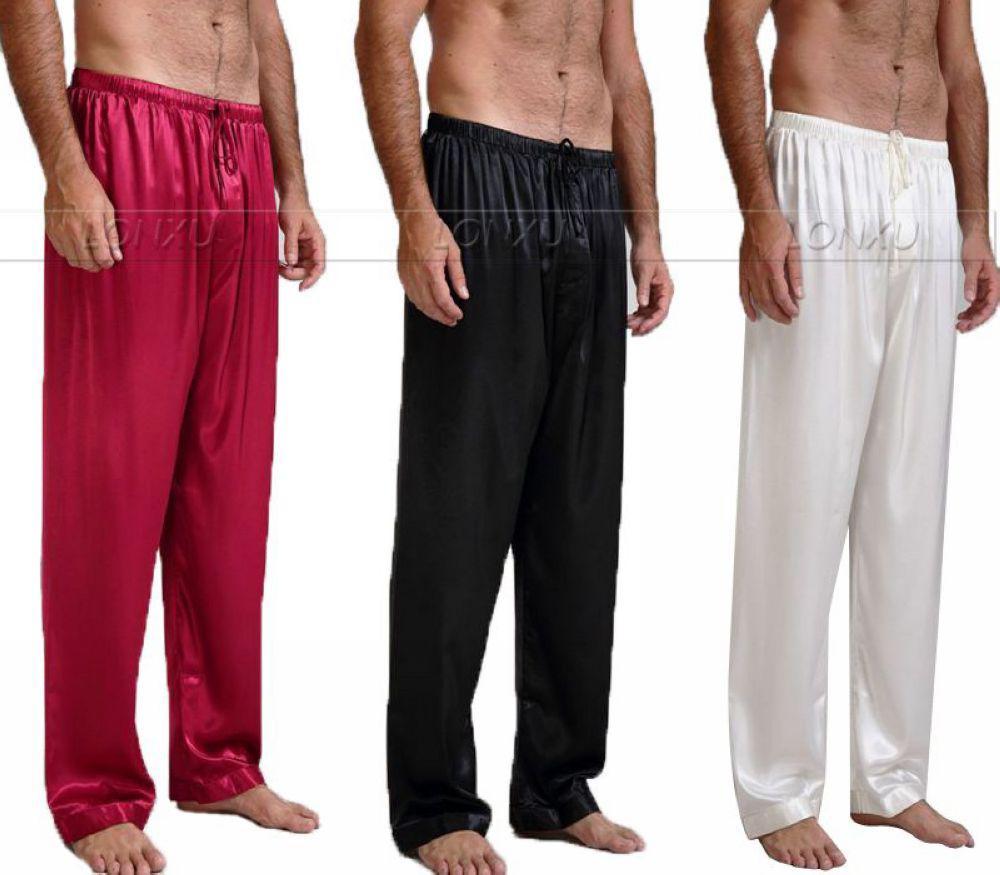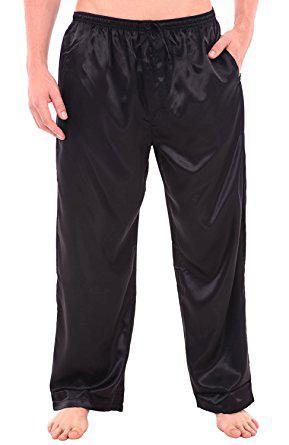The first image is the image on the left, the second image is the image on the right. Evaluate the accuracy of this statement regarding the images: "There are two pairs of pants". Is it true? Answer yes or no. No. 